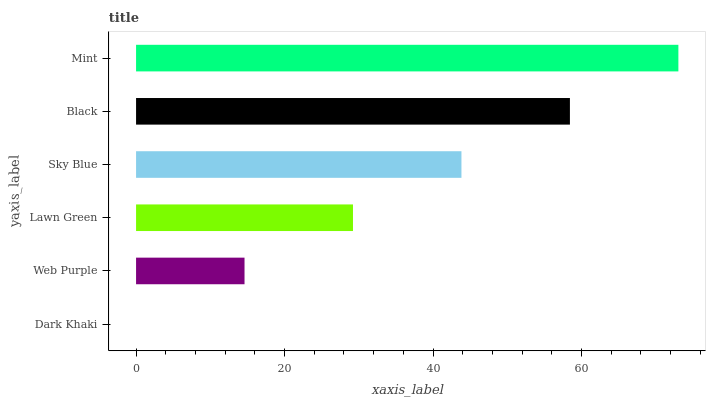Is Dark Khaki the minimum?
Answer yes or no. Yes. Is Mint the maximum?
Answer yes or no. Yes. Is Web Purple the minimum?
Answer yes or no. No. Is Web Purple the maximum?
Answer yes or no. No. Is Web Purple greater than Dark Khaki?
Answer yes or no. Yes. Is Dark Khaki less than Web Purple?
Answer yes or no. Yes. Is Dark Khaki greater than Web Purple?
Answer yes or no. No. Is Web Purple less than Dark Khaki?
Answer yes or no. No. Is Sky Blue the high median?
Answer yes or no. Yes. Is Lawn Green the low median?
Answer yes or no. Yes. Is Dark Khaki the high median?
Answer yes or no. No. Is Web Purple the low median?
Answer yes or no. No. 